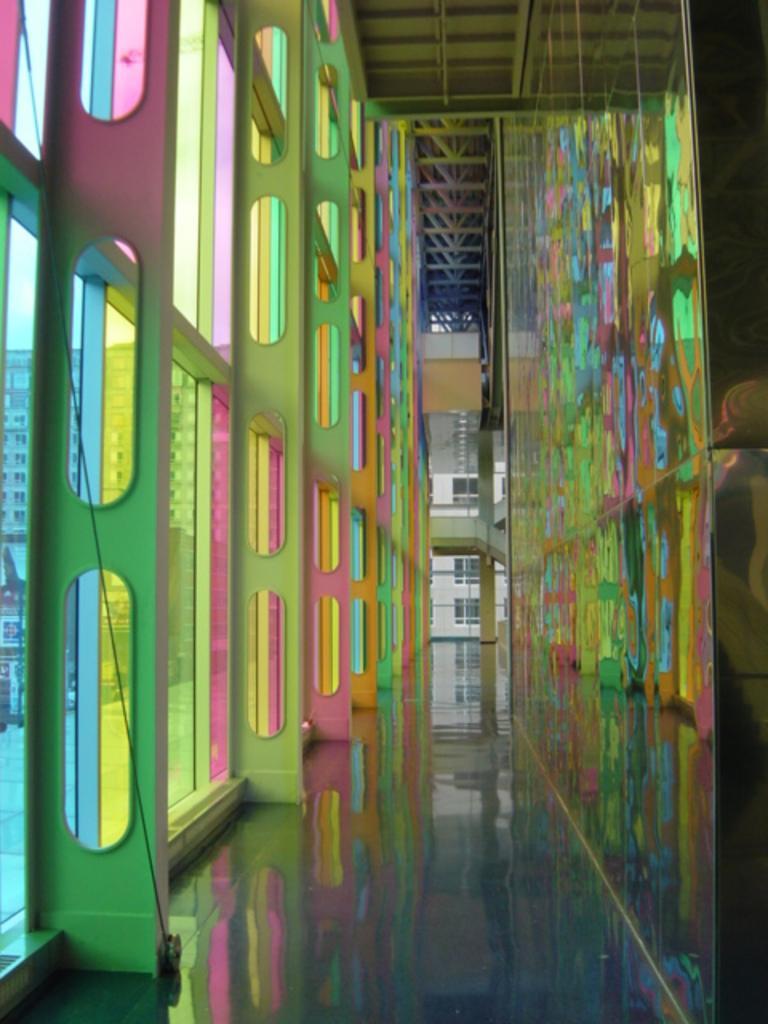Can you describe this image briefly? In this picture I can see the inside view of a building, there are colorful windows, there are trusses, there is a reflection of colorful windows on the transparent glass, and in the background there is a building and the sky. 